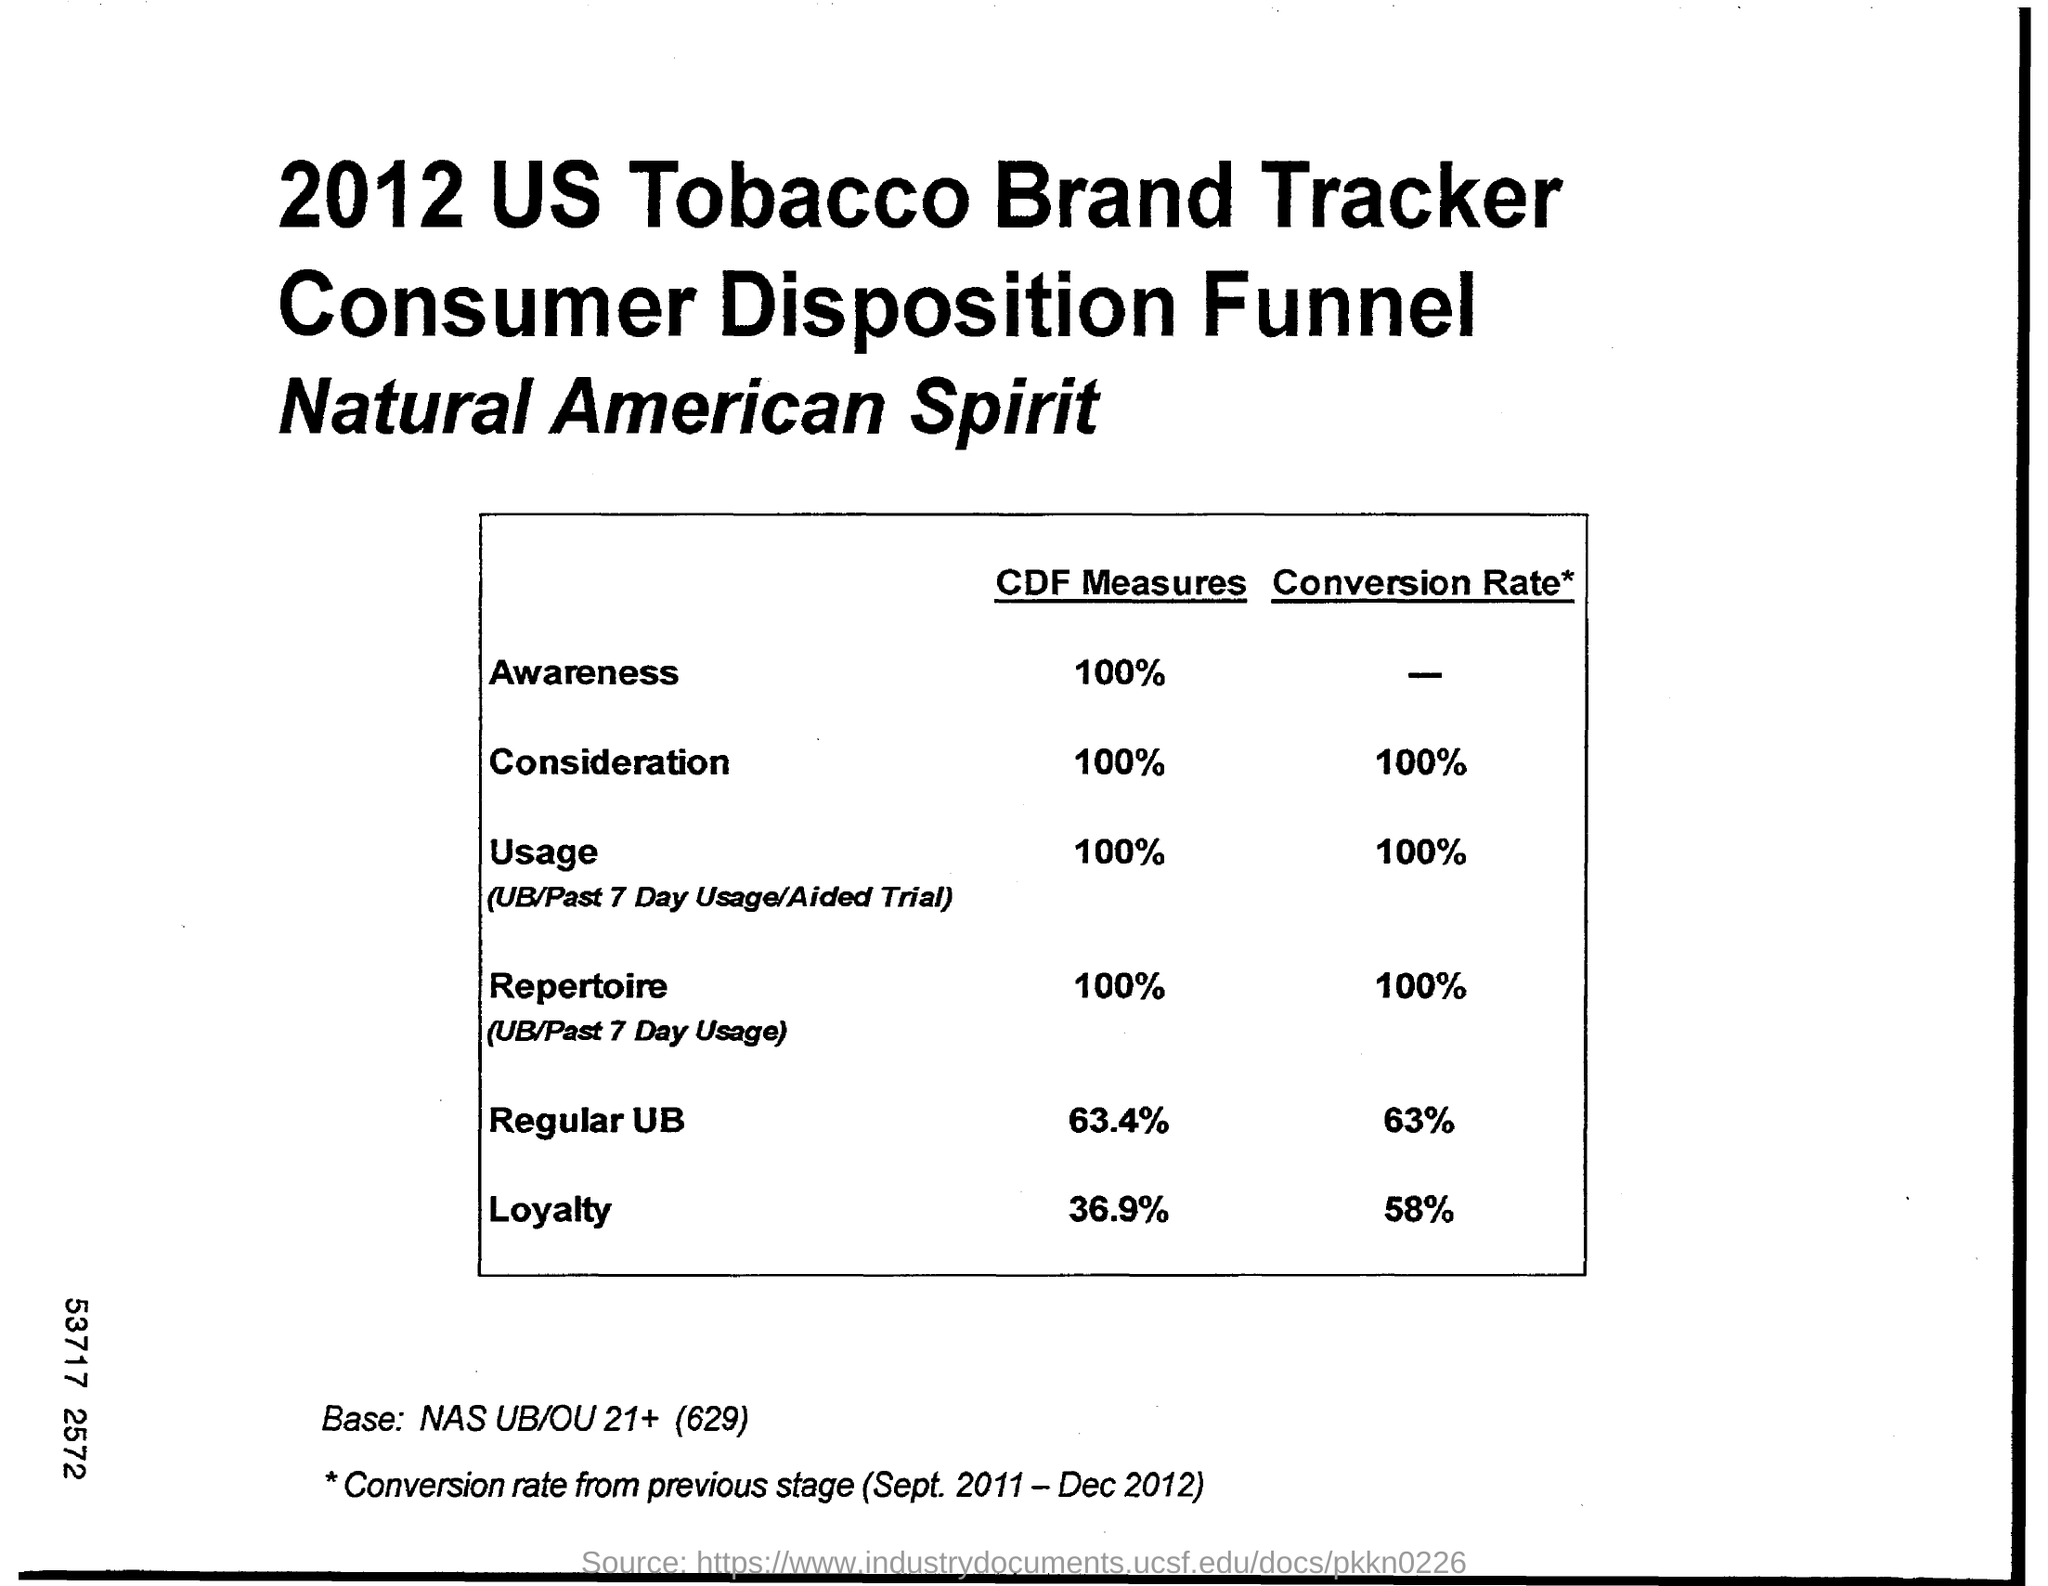What is the Percentage of loyalty according to CDF measures?
Offer a very short reply. 36.9%. 